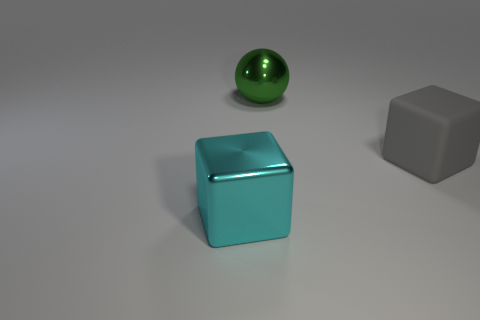Are there any other things that are the same shape as the large green metal thing?
Your answer should be compact. No. Do the large gray cube and the ball have the same material?
Ensure brevity in your answer.  No. How big is the object that is both to the left of the gray object and behind the cyan shiny cube?
Offer a very short reply. Large. How many green spheres are the same size as the cyan thing?
Provide a short and direct response. 1. Does the thing in front of the matte cube have the same shape as the thing that is to the right of the big shiny ball?
Give a very brief answer. Yes. What color is the big object that is both in front of the green shiny thing and on the left side of the large gray rubber object?
Provide a succinct answer. Cyan. What is the color of the object that is behind the big gray object?
Your answer should be very brief. Green. There is a metallic thing that is in front of the large matte thing; are there any gray rubber blocks on the right side of it?
Offer a terse response. Yes. Are there any tiny brown blocks made of the same material as the large cyan cube?
Make the answer very short. No. What number of big yellow rubber cylinders are there?
Give a very brief answer. 0. 